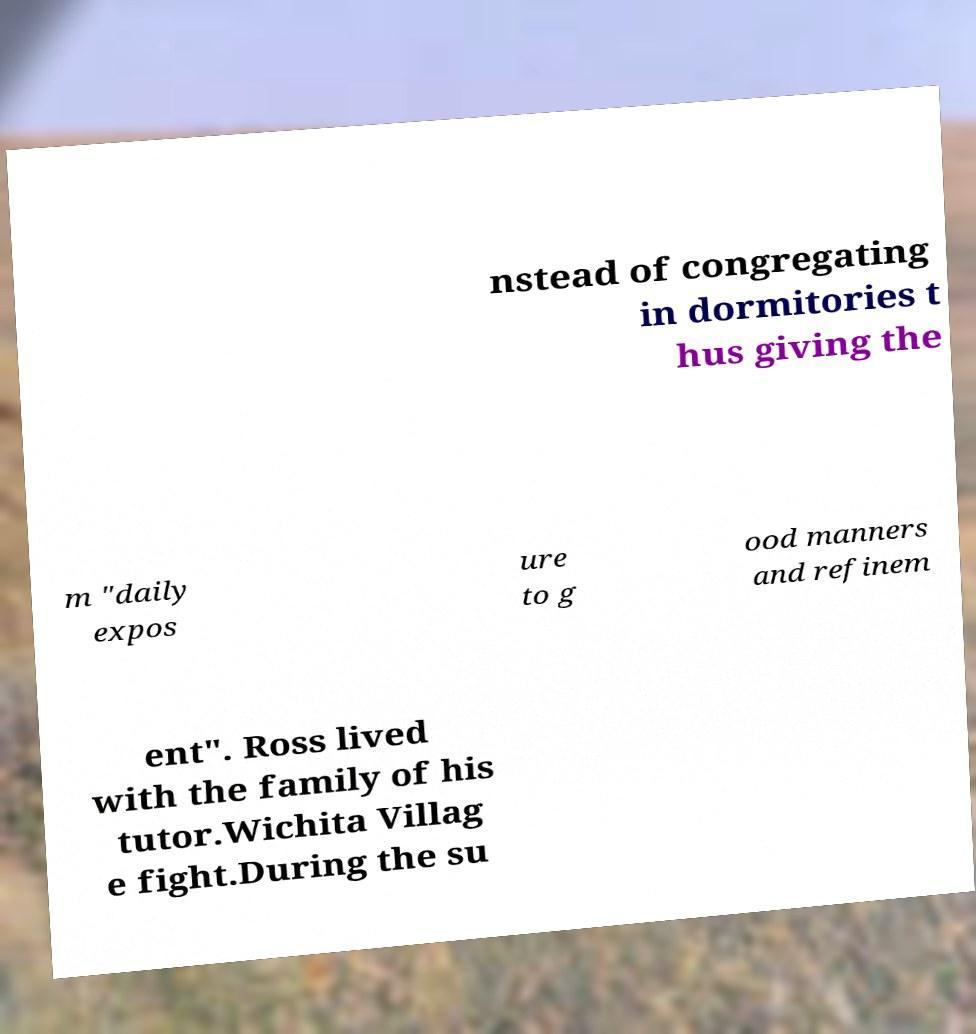Could you extract and type out the text from this image? nstead of congregating in dormitories t hus giving the m "daily expos ure to g ood manners and refinem ent". Ross lived with the family of his tutor.Wichita Villag e fight.During the su 